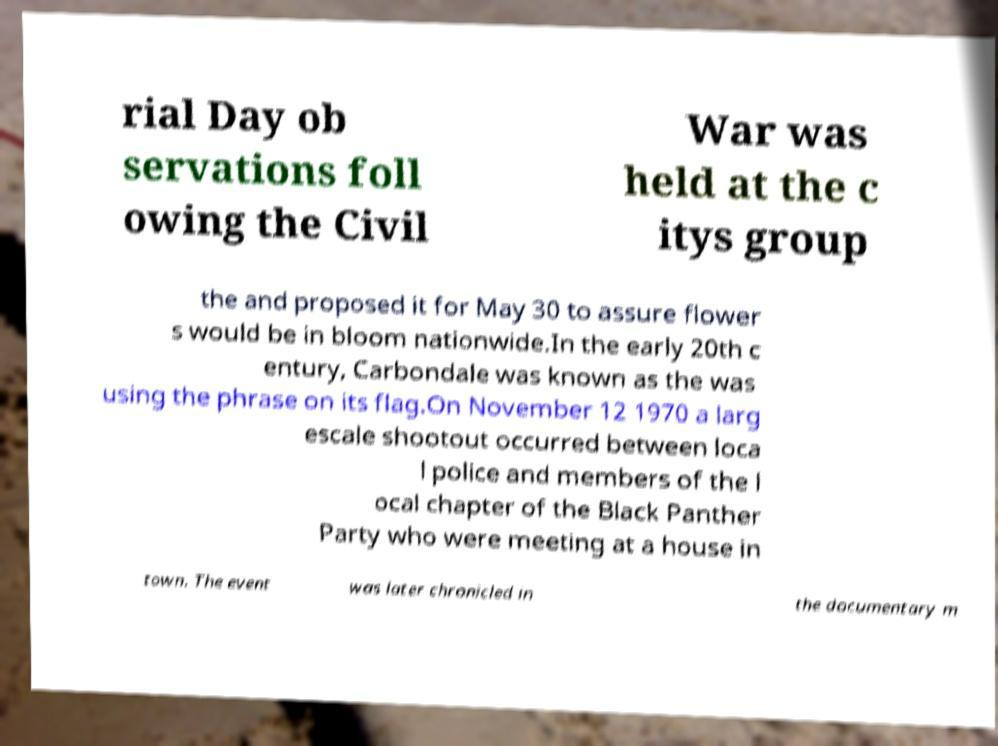I need the written content from this picture converted into text. Can you do that? rial Day ob servations foll owing the Civil War was held at the c itys group the and proposed it for May 30 to assure flower s would be in bloom nationwide.In the early 20th c entury, Carbondale was known as the was using the phrase on its flag.On November 12 1970 a larg escale shootout occurred between loca l police and members of the l ocal chapter of the Black Panther Party who were meeting at a house in town. The event was later chronicled in the documentary m 